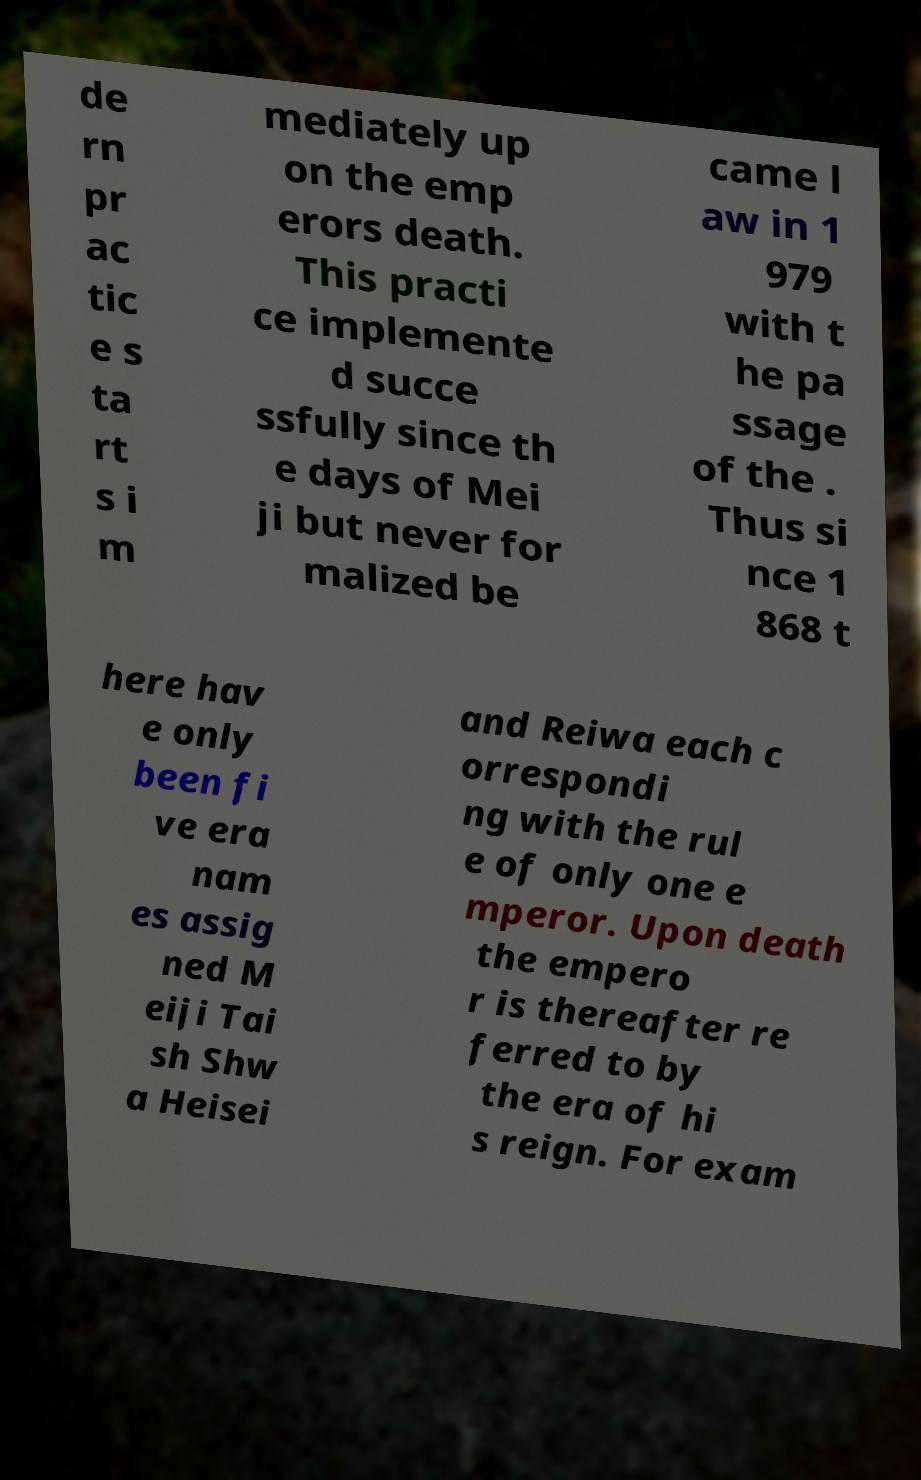Can you read and provide the text displayed in the image?This photo seems to have some interesting text. Can you extract and type it out for me? de rn pr ac tic e s ta rt s i m mediately up on the emp erors death. This practi ce implemente d succe ssfully since th e days of Mei ji but never for malized be came l aw in 1 979 with t he pa ssage of the . Thus si nce 1 868 t here hav e only been fi ve era nam es assig ned M eiji Tai sh Shw a Heisei and Reiwa each c orrespondi ng with the rul e of only one e mperor. Upon death the empero r is thereafter re ferred to by the era of hi s reign. For exam 